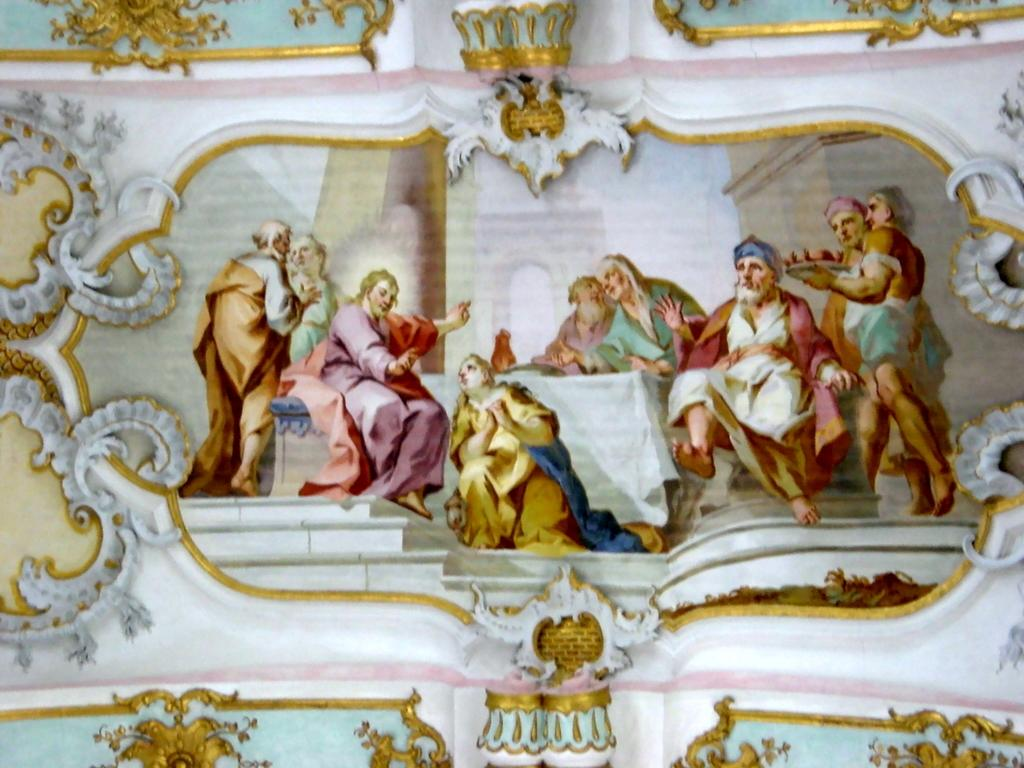How many people are in the image, and what are they wearing? There are people with different color dresses in the image. What is one person doing in the image? One person is holding a plate in the image. Where are the people located in the image? The people are on a wall in the image. Can you describe the appearance of the wall? The wall is colorful. How many mice can be seen running on the wall in the image? There are no mice present in the image; it features people with different color dresses on a wall. What type of spring is visible in the image? There is no spring present in the image. 